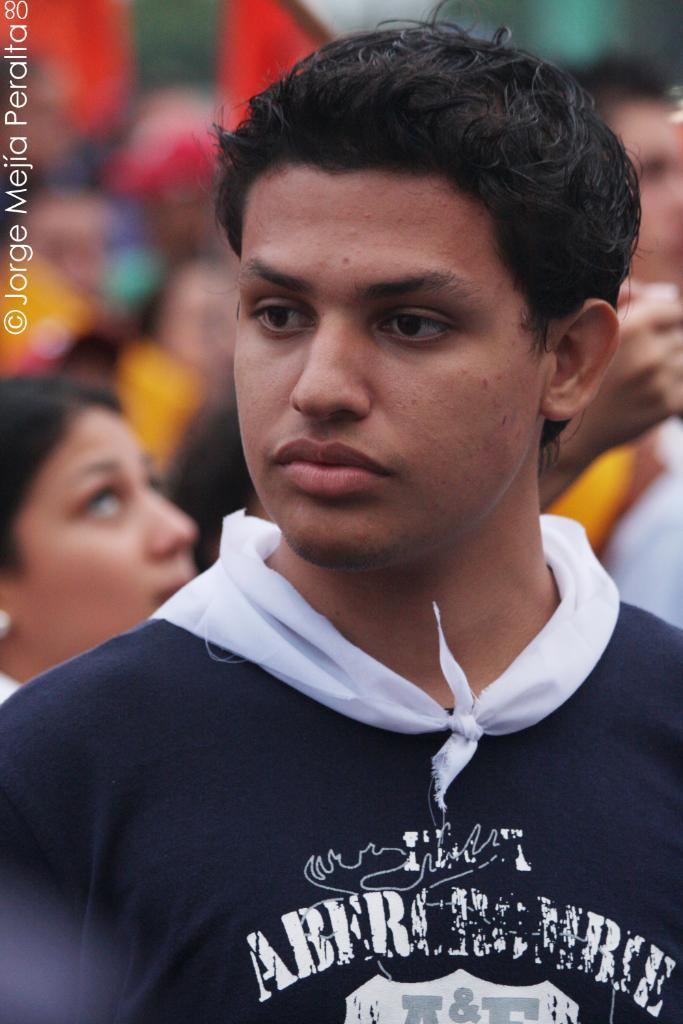In which direction is the person looking in the image? The person is looking to the left side of the image. What can be seen on the left side of the image? There is a watermark on the left side of the image. How would you describe the background of the image? The background of the image is blurry. Can you identify any other people in the image? Yes, there are people visible in the background of the image. How many rings are being held by the person in the image? There are no rings visible in the image. What type of quiver is the person using to store their arrows in the image? There is no quiver or arrows present in the image. 